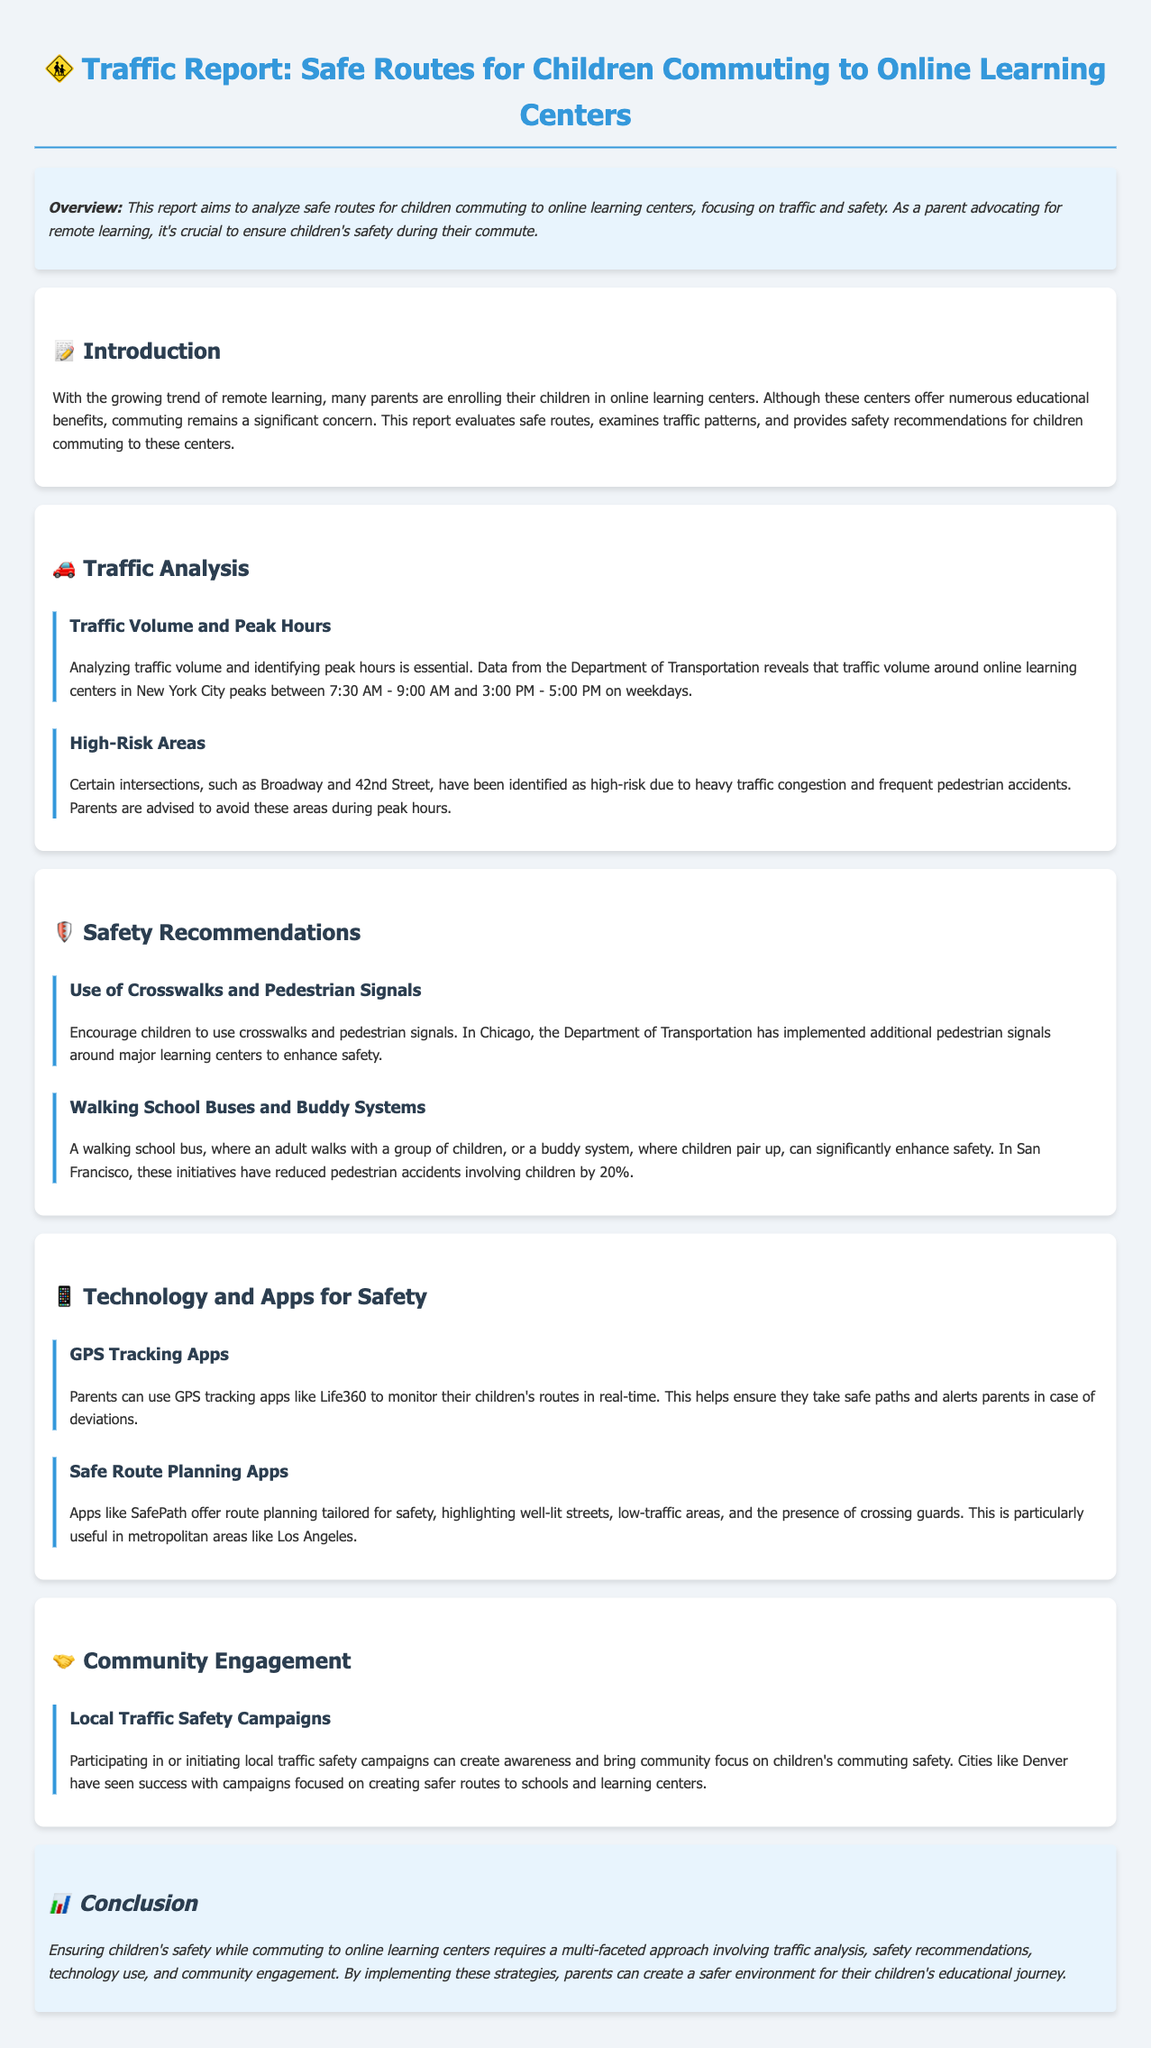What is the peak traffic time around online learning centers? The peak traffic time is identified based on data from the Department of Transportation, specifically between 7:30 AM - 9:00 AM and 3:00 PM - 5:00 PM on weekdays.
Answer: 7:30 AM - 9:00 AM and 3:00 PM - 5:00 PM Which intersection is identified as a high-risk area? The document specifies that Broadway and 42nd Street have been identified as high-risk areas due to heavy traffic and accidents.
Answer: Broadway and 42nd Street What safety initiative has reduced pedestrian accidents by 20%? The report mentions two strategies, one being the walking school bus or buddy system, which has been effective in San Francisco.
Answer: Walking school bus and buddy system What technology can parents use to monitor children's routes? The document refers to GPS tracking apps, giving Life360 as a specific example to monitor children's paths in real-time.
Answer: Life360 What is the purpose of the SafePath app? SafePath is highlighted for its ability to plan safe routes emphasizing well-lit streets and low-traffic areas, especially useful in urban settings.
Answer: Route planning tailored for safety 